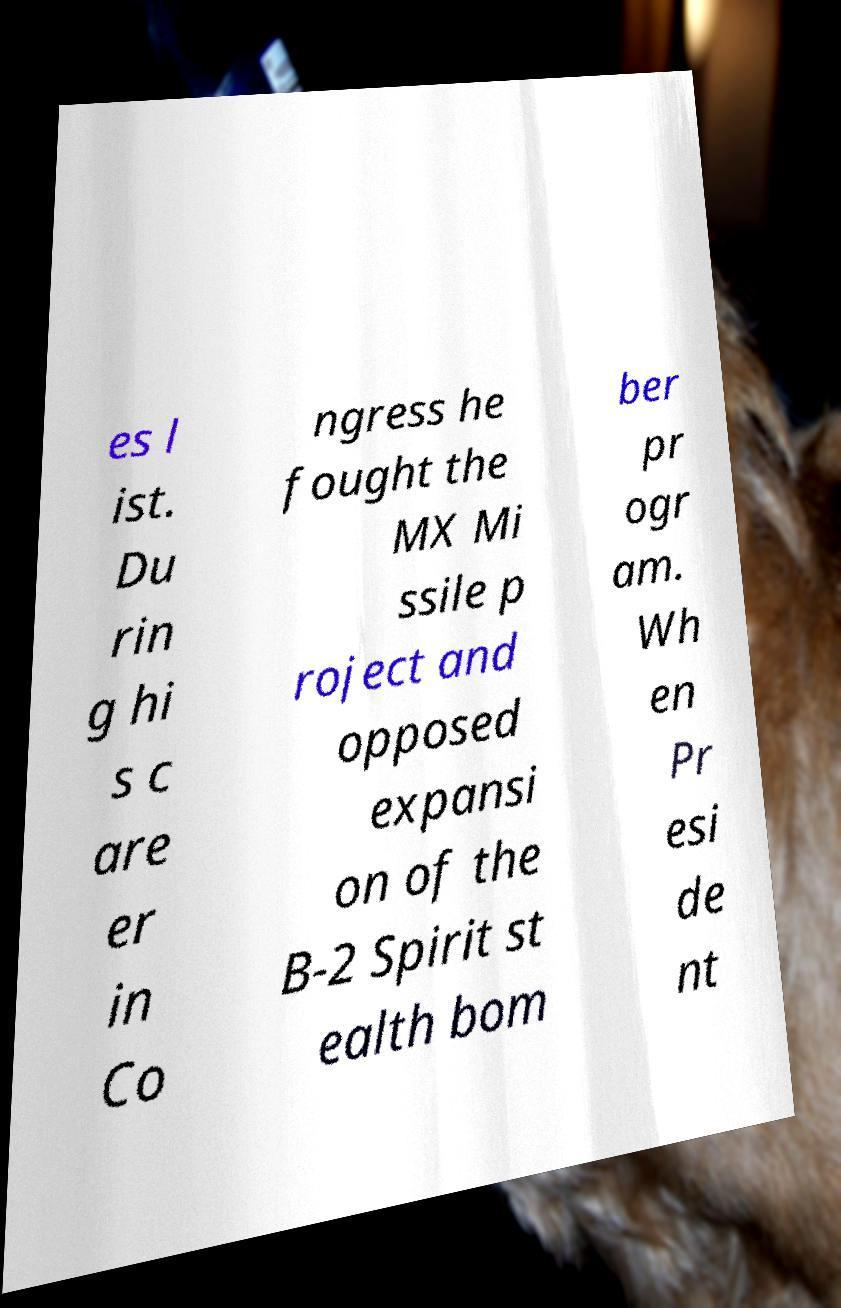There's text embedded in this image that I need extracted. Can you transcribe it verbatim? es l ist. Du rin g hi s c are er in Co ngress he fought the MX Mi ssile p roject and opposed expansi on of the B-2 Spirit st ealth bom ber pr ogr am. Wh en Pr esi de nt 